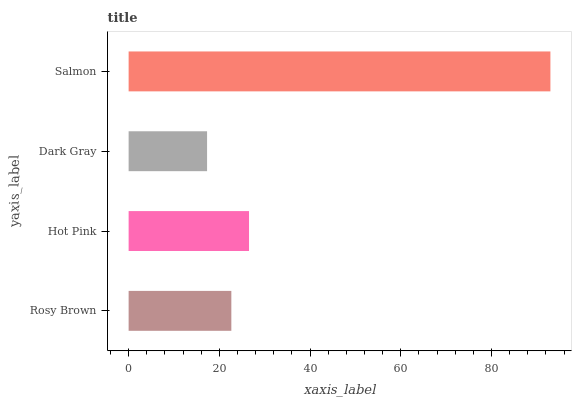Is Dark Gray the minimum?
Answer yes or no. Yes. Is Salmon the maximum?
Answer yes or no. Yes. Is Hot Pink the minimum?
Answer yes or no. No. Is Hot Pink the maximum?
Answer yes or no. No. Is Hot Pink greater than Rosy Brown?
Answer yes or no. Yes. Is Rosy Brown less than Hot Pink?
Answer yes or no. Yes. Is Rosy Brown greater than Hot Pink?
Answer yes or no. No. Is Hot Pink less than Rosy Brown?
Answer yes or no. No. Is Hot Pink the high median?
Answer yes or no. Yes. Is Rosy Brown the low median?
Answer yes or no. Yes. Is Salmon the high median?
Answer yes or no. No. Is Dark Gray the low median?
Answer yes or no. No. 